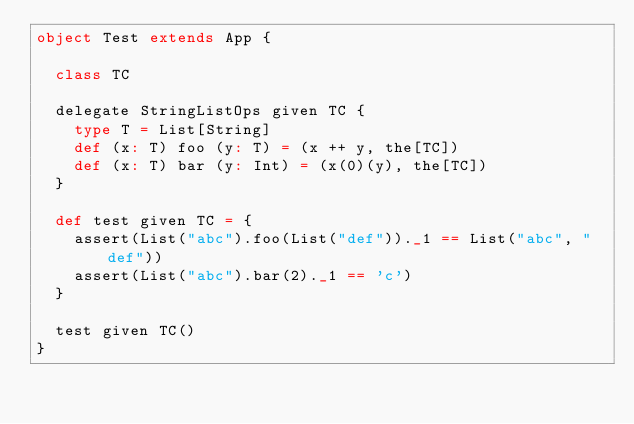Convert code to text. <code><loc_0><loc_0><loc_500><loc_500><_Scala_>object Test extends App {

  class TC

  delegate StringListOps given TC {
    type T = List[String]
    def (x: T) foo (y: T) = (x ++ y, the[TC])
    def (x: T) bar (y: Int) = (x(0)(y), the[TC])
  }

  def test given TC = {
    assert(List("abc").foo(List("def"))._1 == List("abc", "def"))
    assert(List("abc").bar(2)._1 == 'c')
  }

  test given TC()
}</code> 